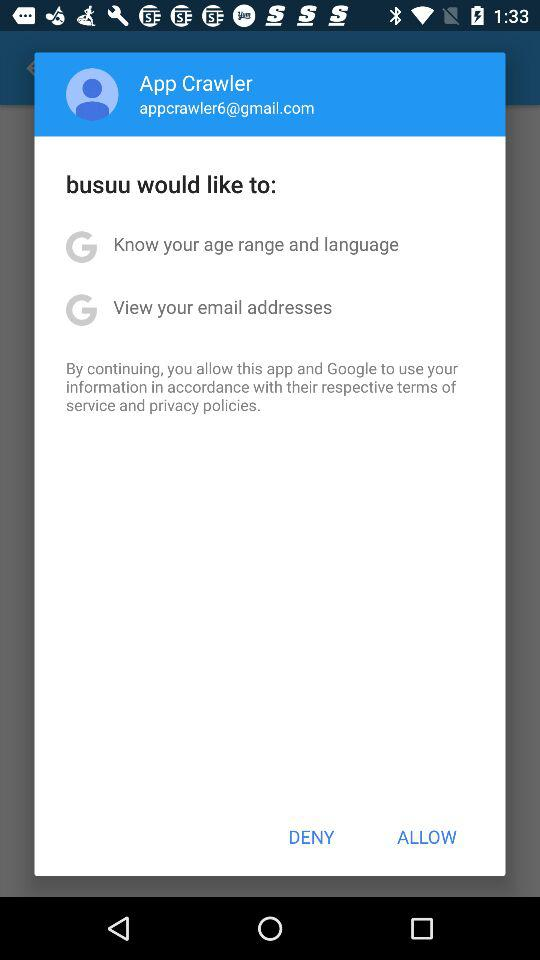How many items does the user need to accept to continue?
Answer the question using a single word or phrase. 2 